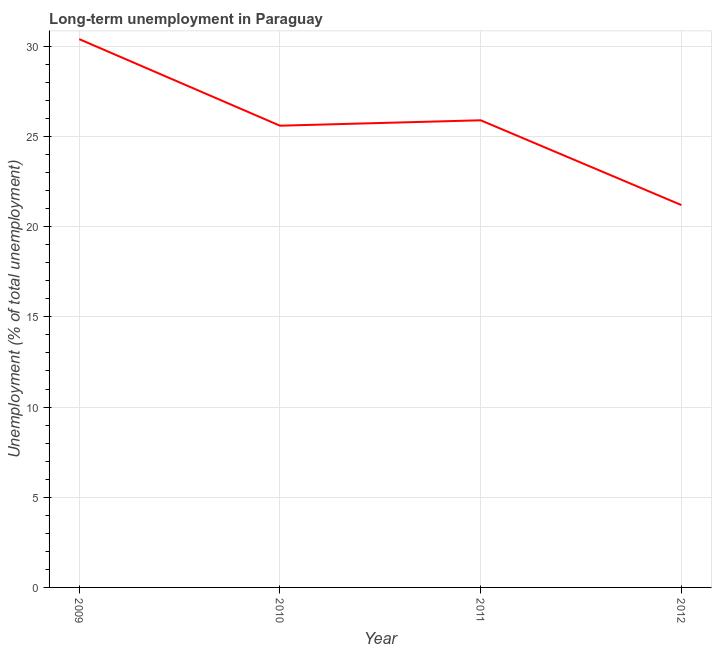What is the long-term unemployment in 2009?
Your response must be concise. 30.4. Across all years, what is the maximum long-term unemployment?
Make the answer very short. 30.4. Across all years, what is the minimum long-term unemployment?
Your response must be concise. 21.2. In which year was the long-term unemployment minimum?
Offer a very short reply. 2012. What is the sum of the long-term unemployment?
Your response must be concise. 103.1. What is the difference between the long-term unemployment in 2010 and 2012?
Your response must be concise. 4.4. What is the average long-term unemployment per year?
Your answer should be very brief. 25.78. What is the median long-term unemployment?
Offer a terse response. 25.75. In how many years, is the long-term unemployment greater than 20 %?
Your answer should be very brief. 4. Do a majority of the years between 2011 and 2012 (inclusive) have long-term unemployment greater than 5 %?
Offer a terse response. Yes. What is the ratio of the long-term unemployment in 2009 to that in 2012?
Give a very brief answer. 1.43. What is the difference between the highest and the second highest long-term unemployment?
Make the answer very short. 4.5. What is the difference between the highest and the lowest long-term unemployment?
Ensure brevity in your answer.  9.2. How many lines are there?
Provide a short and direct response. 1. How many years are there in the graph?
Your response must be concise. 4. What is the difference between two consecutive major ticks on the Y-axis?
Keep it short and to the point. 5. Does the graph contain any zero values?
Offer a terse response. No. Does the graph contain grids?
Your answer should be compact. Yes. What is the title of the graph?
Provide a succinct answer. Long-term unemployment in Paraguay. What is the label or title of the X-axis?
Offer a terse response. Year. What is the label or title of the Y-axis?
Make the answer very short. Unemployment (% of total unemployment). What is the Unemployment (% of total unemployment) in 2009?
Your response must be concise. 30.4. What is the Unemployment (% of total unemployment) in 2010?
Your answer should be very brief. 25.6. What is the Unemployment (% of total unemployment) in 2011?
Ensure brevity in your answer.  25.9. What is the Unemployment (% of total unemployment) of 2012?
Provide a succinct answer. 21.2. What is the difference between the Unemployment (% of total unemployment) in 2009 and 2011?
Make the answer very short. 4.5. What is the difference between the Unemployment (% of total unemployment) in 2010 and 2011?
Make the answer very short. -0.3. What is the difference between the Unemployment (% of total unemployment) in 2011 and 2012?
Your answer should be compact. 4.7. What is the ratio of the Unemployment (% of total unemployment) in 2009 to that in 2010?
Your response must be concise. 1.19. What is the ratio of the Unemployment (% of total unemployment) in 2009 to that in 2011?
Your answer should be very brief. 1.17. What is the ratio of the Unemployment (% of total unemployment) in 2009 to that in 2012?
Ensure brevity in your answer.  1.43. What is the ratio of the Unemployment (% of total unemployment) in 2010 to that in 2011?
Offer a terse response. 0.99. What is the ratio of the Unemployment (% of total unemployment) in 2010 to that in 2012?
Offer a terse response. 1.21. What is the ratio of the Unemployment (% of total unemployment) in 2011 to that in 2012?
Provide a short and direct response. 1.22. 